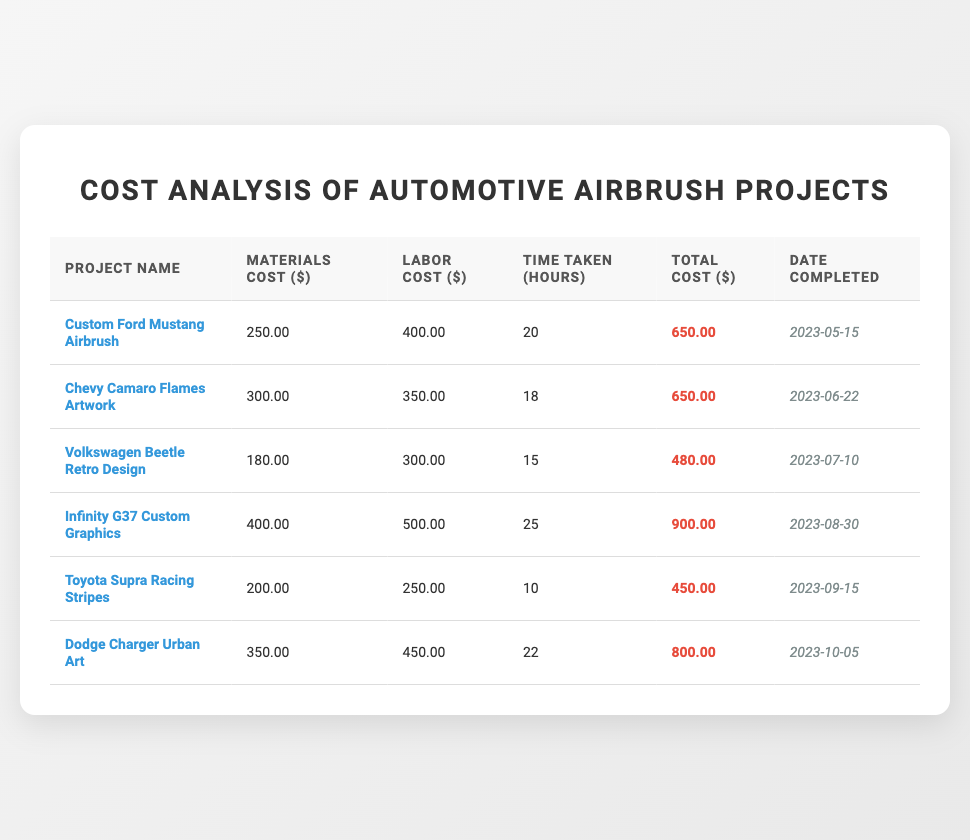What was the total cost of the Infinity G37 Custom Graphics project? The total cost for the Infinity G37 Custom Graphics project is listed in the table as 900.00.
Answer: 900.00 How much did the Dodge Charger Urban Art project cost in terms of materials? The materials cost for the Dodge Charger Urban Art project is recorded in the table as 350.00.
Answer: 350.00 Which project took the longest time to complete, and how many hours did it take? The Infinity G37 Custom Graphics project took the longest time at 25 hours, as listed in the Time Taken (Hours) column.
Answer: Infinity G37 Custom Graphics, 25 hours What is the average total cost of all the projects listed? The total costs for all projects are: 650.00 + 650.00 + 480.00 + 900.00 + 450.00 + 800.00 = 3980.00. Dividing this by the 6 projects gives an average of 663.33.
Answer: 663.33 Was the materials cost for the Volkswagen Beetle Retro Design project greater than its labor cost? The materials cost is 180.00 and the labor cost is 300.00; since 180.00 is less than 300.00, the answer is no.
Answer: No How much more did the Chevy Camaro Flames Artwork project cost compared to the Toyota Supra Racing Stripes project? The total cost of the Chevy Camaro Flames Artwork project is 650.00 and for the Toyota Supra Racing Stripes project, it is 450.00. The difference is 650.00 - 450.00 = 200.00.
Answer: 200.00 Did the projects completed in June have a higher average labor cost compared to those completed in September? The projects completed in June had a labor cost of 350.00 (Chevy Camaro Flames Artwork), while September had a labor cost of 250.00 (Toyota Supra Racing Stripes). The average for June is higher than September's.
Answer: Yes How many hours did the Custom Ford Mustang Airbrush and Dodge Charger Urban Art projects take in total? The Custom Ford Mustang Airbrush took 20 hours and the Dodge Charger Urban Art took 22 hours. Adding these gives 20 + 22 = 42 hours total.
Answer: 42 hours What was the total material cost for all the projects combined? The total material costs are: 250.00 (Ford Mustang) + 300.00 (Chevy Camaro) + 180.00 (Volkswagen) + 400.00 (Infinity) + 200.00 (Toyota) + 350.00 (Dodge) = 1680.00.
Answer: 1680.00 